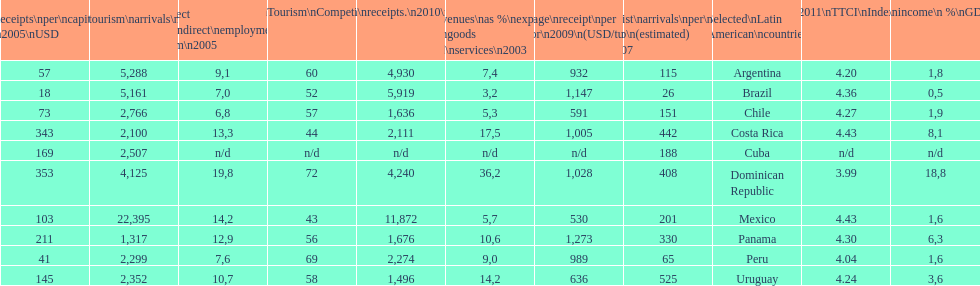Which latin american country had the largest number of tourism arrivals in 2010? Mexico. 